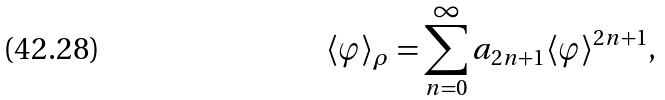<formula> <loc_0><loc_0><loc_500><loc_500>\langle \varphi \rangle _ { \rho } = \sum _ { n = 0 } ^ { \infty } a _ { 2 n + 1 } \langle \varphi \rangle ^ { 2 n + 1 } ,</formula> 